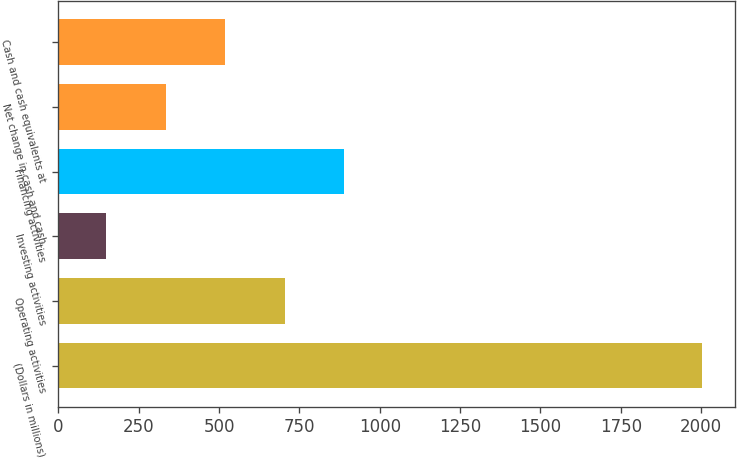<chart> <loc_0><loc_0><loc_500><loc_500><bar_chart><fcel>(Dollars in millions)<fcel>Operating activities<fcel>Investing activities<fcel>Financing activities<fcel>Net change in cash and cash<fcel>Cash and cash equivalents at<nl><fcel>2004<fcel>704.8<fcel>148<fcel>890.4<fcel>333.6<fcel>519.2<nl></chart> 